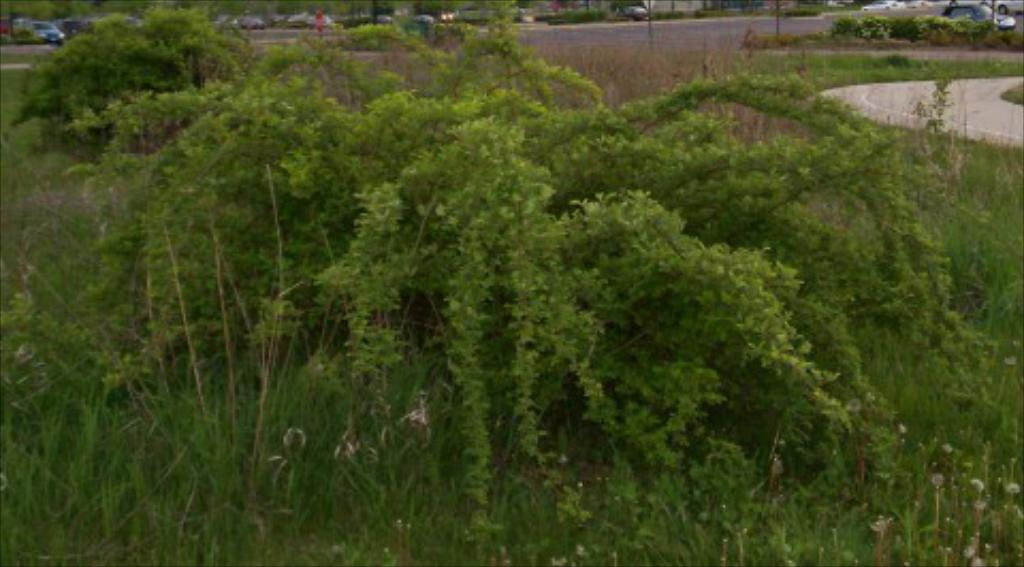What type of vegetation can be seen in the image? There is grass and trees in the image. What man-made structure is present in the image? There is a road in the image. What can be seen in the background of the image? Vehicles, poles, and plants are visible in the background of the image. Can you see the geese smiling with their tongues out in the image? There are no geese or any indication of smiling or tongues in the image. 